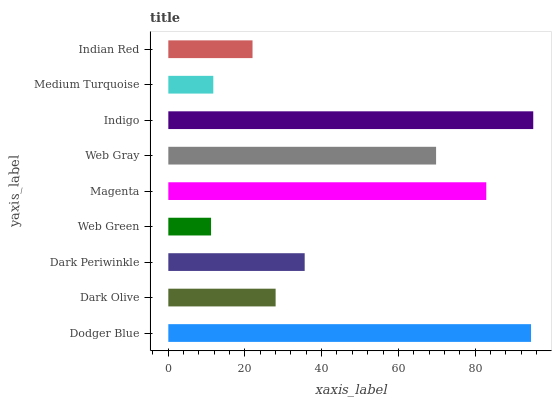Is Web Green the minimum?
Answer yes or no. Yes. Is Indigo the maximum?
Answer yes or no. Yes. Is Dark Olive the minimum?
Answer yes or no. No. Is Dark Olive the maximum?
Answer yes or no. No. Is Dodger Blue greater than Dark Olive?
Answer yes or no. Yes. Is Dark Olive less than Dodger Blue?
Answer yes or no. Yes. Is Dark Olive greater than Dodger Blue?
Answer yes or no. No. Is Dodger Blue less than Dark Olive?
Answer yes or no. No. Is Dark Periwinkle the high median?
Answer yes or no. Yes. Is Dark Periwinkle the low median?
Answer yes or no. Yes. Is Web Gray the high median?
Answer yes or no. No. Is Web Gray the low median?
Answer yes or no. No. 